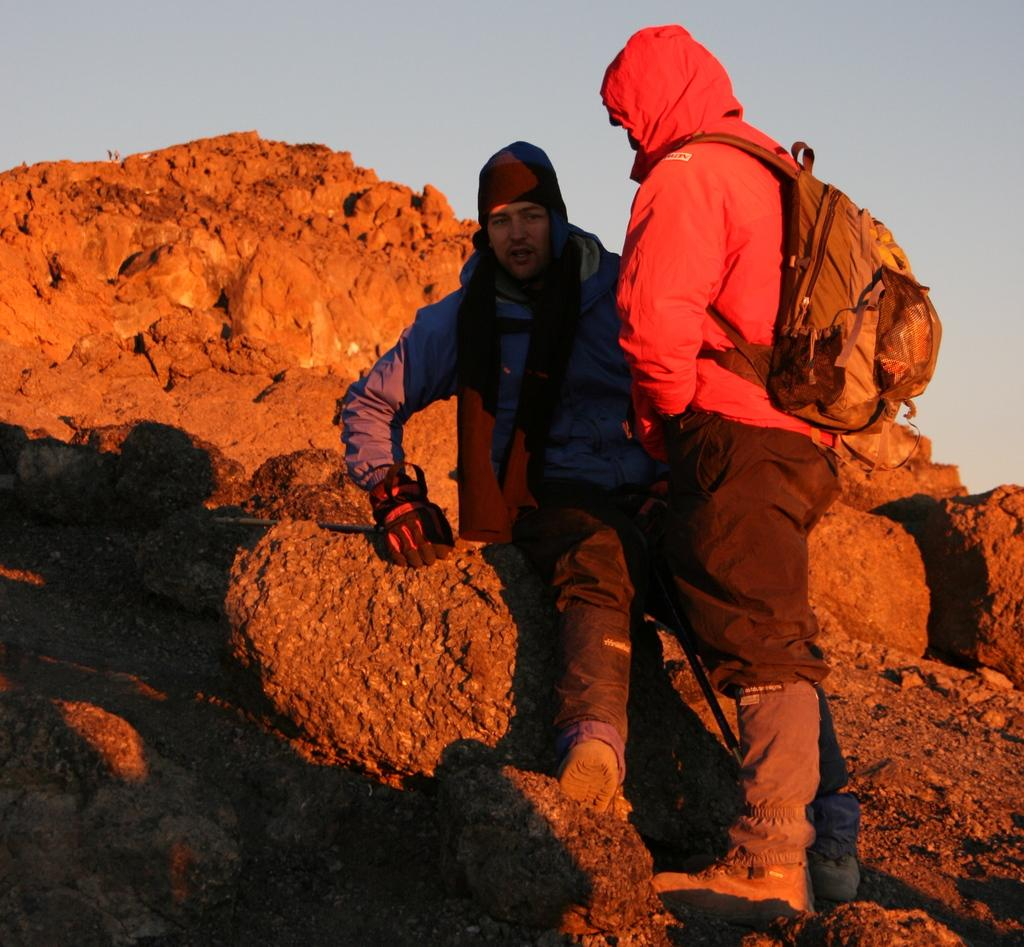What is the main feature of the landscape in the image? There is a hill in the image. Are there any people on the hill? Yes, there are two persons on the hill. Can you describe one of the persons on the hill? One person on the hill is wearing a backpack. What can be seen at the top of the hill? The sky is visible at the top of the hill. What type of birthday celebration is happening on the hill in the image? There is no indication of a birthday celebration in the image; it simply shows two persons on a hill. Can you hear the goose laughing in the image? There is no goose present in the image, so it cannot be heard laughing. 